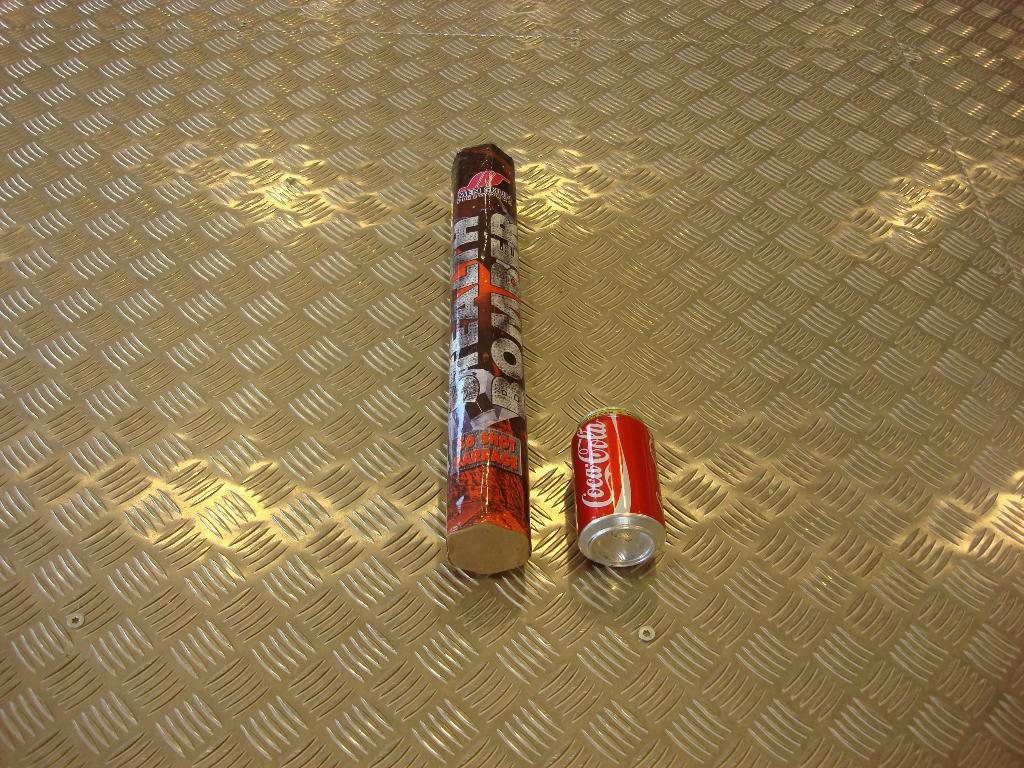<image>
Create a compact narrative representing the image presented. A can of Coca-cola is lying on its side on a metal surface. 